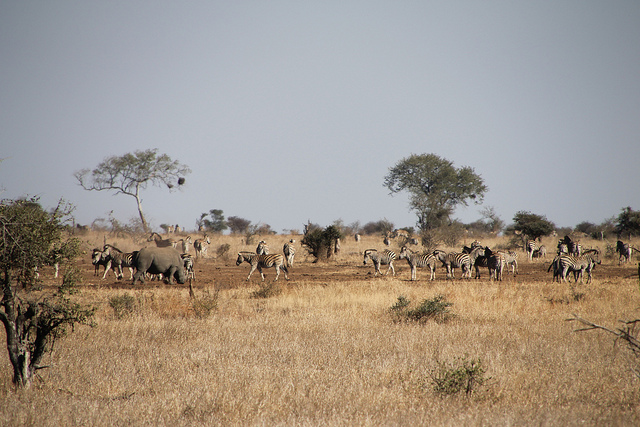Did it rain a short or long time ago? Given the dry and brown coloration of the grasses and no visible signs of wet ground or recent water accumulation, it appears that it rained a considerable time ago, rather than recently. 